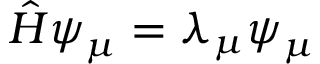<formula> <loc_0><loc_0><loc_500><loc_500>{ \hat { H } } \psi _ { \mu } = \lambda _ { \mu } \psi _ { \mu }</formula> 